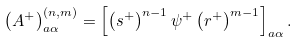Convert formula to latex. <formula><loc_0><loc_0><loc_500><loc_500>\left ( A ^ { + } \right ) _ { a \alpha } ^ { \left ( n , m \right ) } = \left [ \left ( s ^ { + } \right ) ^ { n - 1 } \psi ^ { + } \left ( r ^ { + } \right ) ^ { m - 1 } \right ] _ { a \alpha } .</formula> 